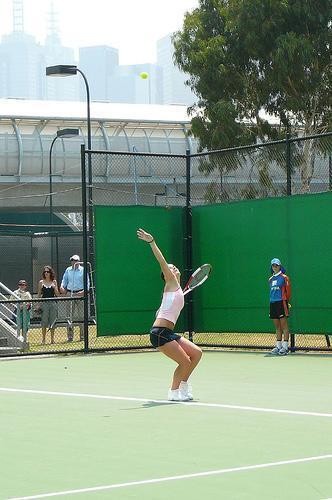How many women holding the racket?
Give a very brief answer. 1. How many people are wearing blue shirts?
Give a very brief answer. 2. 